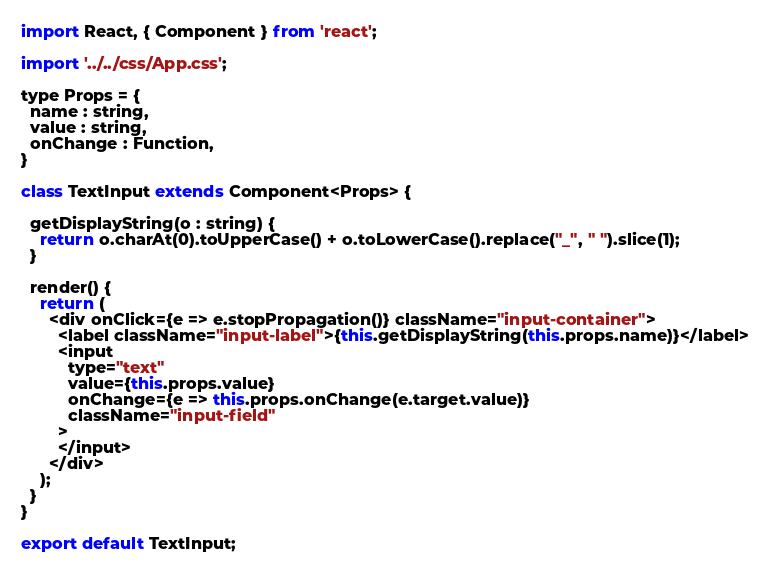<code> <loc_0><loc_0><loc_500><loc_500><_JavaScript_>import React, { Component } from 'react';

import '../../css/App.css';

type Props = {
  name : string,
  value : string,
  onChange : Function,
}

class TextInput extends Component<Props> {

  getDisplayString(o : string) {
    return o.charAt(0).toUpperCase() + o.toLowerCase().replace("_", " ").slice(1);
  }

  render() {
    return (
      <div onClick={e => e.stopPropagation()} className="input-container">
        <label className="input-label">{this.getDisplayString(this.props.name)}</label>
        <input
          type="text"
          value={this.props.value}
          onChange={e => this.props.onChange(e.target.value)}
          className="input-field"
        >
        </input>
      </div>
    );
  }
}

export default TextInput;
</code> 